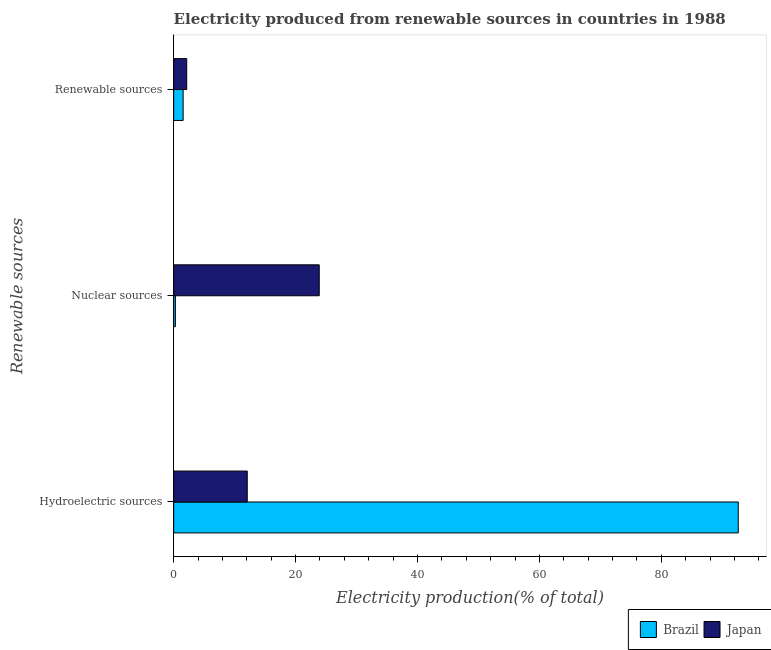How many different coloured bars are there?
Offer a terse response. 2. Are the number of bars per tick equal to the number of legend labels?
Offer a very short reply. Yes. How many bars are there on the 2nd tick from the bottom?
Offer a very short reply. 2. What is the label of the 3rd group of bars from the top?
Keep it short and to the point. Hydroelectric sources. What is the percentage of electricity produced by renewable sources in Brazil?
Make the answer very short. 1.55. Across all countries, what is the maximum percentage of electricity produced by renewable sources?
Give a very brief answer. 2.14. Across all countries, what is the minimum percentage of electricity produced by hydroelectric sources?
Your response must be concise. 12.07. What is the total percentage of electricity produced by nuclear sources in the graph?
Your answer should be compact. 24.16. What is the difference between the percentage of electricity produced by nuclear sources in Japan and that in Brazil?
Your answer should be compact. 23.6. What is the difference between the percentage of electricity produced by renewable sources in Brazil and the percentage of electricity produced by nuclear sources in Japan?
Your answer should be very brief. -22.33. What is the average percentage of electricity produced by nuclear sources per country?
Provide a succinct answer. 12.08. What is the difference between the percentage of electricity produced by nuclear sources and percentage of electricity produced by renewable sources in Japan?
Ensure brevity in your answer.  21.74. In how many countries, is the percentage of electricity produced by renewable sources greater than 4 %?
Offer a terse response. 0. What is the ratio of the percentage of electricity produced by nuclear sources in Japan to that in Brazil?
Your answer should be compact. 84.43. Is the percentage of electricity produced by nuclear sources in Brazil less than that in Japan?
Make the answer very short. Yes. Is the difference between the percentage of electricity produced by renewable sources in Japan and Brazil greater than the difference between the percentage of electricity produced by nuclear sources in Japan and Brazil?
Ensure brevity in your answer.  No. What is the difference between the highest and the second highest percentage of electricity produced by renewable sources?
Ensure brevity in your answer.  0.58. What is the difference between the highest and the lowest percentage of electricity produced by hydroelectric sources?
Offer a very short reply. 80.56. In how many countries, is the percentage of electricity produced by nuclear sources greater than the average percentage of electricity produced by nuclear sources taken over all countries?
Your answer should be very brief. 1. Is the sum of the percentage of electricity produced by hydroelectric sources in Brazil and Japan greater than the maximum percentage of electricity produced by nuclear sources across all countries?
Provide a succinct answer. Yes. What does the 2nd bar from the bottom in Hydroelectric sources represents?
Ensure brevity in your answer.  Japan. Is it the case that in every country, the sum of the percentage of electricity produced by hydroelectric sources and percentage of electricity produced by nuclear sources is greater than the percentage of electricity produced by renewable sources?
Offer a very short reply. Yes. Are all the bars in the graph horizontal?
Keep it short and to the point. Yes. What is the difference between two consecutive major ticks on the X-axis?
Keep it short and to the point. 20. Are the values on the major ticks of X-axis written in scientific E-notation?
Make the answer very short. No. Does the graph contain grids?
Your response must be concise. No. Where does the legend appear in the graph?
Your answer should be very brief. Bottom right. How many legend labels are there?
Ensure brevity in your answer.  2. What is the title of the graph?
Your answer should be very brief. Electricity produced from renewable sources in countries in 1988. Does "Cuba" appear as one of the legend labels in the graph?
Offer a terse response. No. What is the label or title of the X-axis?
Make the answer very short. Electricity production(% of total). What is the label or title of the Y-axis?
Your response must be concise. Renewable sources. What is the Electricity production(% of total) in Brazil in Hydroelectric sources?
Keep it short and to the point. 92.62. What is the Electricity production(% of total) in Japan in Hydroelectric sources?
Offer a very short reply. 12.07. What is the Electricity production(% of total) in Brazil in Nuclear sources?
Keep it short and to the point. 0.28. What is the Electricity production(% of total) of Japan in Nuclear sources?
Make the answer very short. 23.88. What is the Electricity production(% of total) in Brazil in Renewable sources?
Make the answer very short. 1.55. What is the Electricity production(% of total) in Japan in Renewable sources?
Your answer should be compact. 2.14. Across all Renewable sources, what is the maximum Electricity production(% of total) of Brazil?
Ensure brevity in your answer.  92.62. Across all Renewable sources, what is the maximum Electricity production(% of total) in Japan?
Give a very brief answer. 23.88. Across all Renewable sources, what is the minimum Electricity production(% of total) of Brazil?
Make the answer very short. 0.28. Across all Renewable sources, what is the minimum Electricity production(% of total) of Japan?
Your response must be concise. 2.14. What is the total Electricity production(% of total) in Brazil in the graph?
Provide a succinct answer. 94.46. What is the total Electricity production(% of total) in Japan in the graph?
Give a very brief answer. 38.09. What is the difference between the Electricity production(% of total) of Brazil in Hydroelectric sources and that in Nuclear sources?
Ensure brevity in your answer.  92.34. What is the difference between the Electricity production(% of total) in Japan in Hydroelectric sources and that in Nuclear sources?
Give a very brief answer. -11.81. What is the difference between the Electricity production(% of total) in Brazil in Hydroelectric sources and that in Renewable sources?
Your answer should be compact. 91.07. What is the difference between the Electricity production(% of total) in Japan in Hydroelectric sources and that in Renewable sources?
Give a very brief answer. 9.93. What is the difference between the Electricity production(% of total) of Brazil in Nuclear sources and that in Renewable sources?
Give a very brief answer. -1.27. What is the difference between the Electricity production(% of total) of Japan in Nuclear sources and that in Renewable sources?
Your answer should be compact. 21.74. What is the difference between the Electricity production(% of total) in Brazil in Hydroelectric sources and the Electricity production(% of total) in Japan in Nuclear sources?
Offer a terse response. 68.74. What is the difference between the Electricity production(% of total) in Brazil in Hydroelectric sources and the Electricity production(% of total) in Japan in Renewable sources?
Make the answer very short. 90.49. What is the difference between the Electricity production(% of total) in Brazil in Nuclear sources and the Electricity production(% of total) in Japan in Renewable sources?
Your answer should be very brief. -1.85. What is the average Electricity production(% of total) in Brazil per Renewable sources?
Give a very brief answer. 31.49. What is the average Electricity production(% of total) in Japan per Renewable sources?
Keep it short and to the point. 12.7. What is the difference between the Electricity production(% of total) in Brazil and Electricity production(% of total) in Japan in Hydroelectric sources?
Provide a short and direct response. 80.56. What is the difference between the Electricity production(% of total) of Brazil and Electricity production(% of total) of Japan in Nuclear sources?
Provide a succinct answer. -23.6. What is the difference between the Electricity production(% of total) in Brazil and Electricity production(% of total) in Japan in Renewable sources?
Your answer should be compact. -0.58. What is the ratio of the Electricity production(% of total) of Brazil in Hydroelectric sources to that in Nuclear sources?
Provide a short and direct response. 327.46. What is the ratio of the Electricity production(% of total) of Japan in Hydroelectric sources to that in Nuclear sources?
Ensure brevity in your answer.  0.51. What is the ratio of the Electricity production(% of total) in Brazil in Hydroelectric sources to that in Renewable sources?
Keep it short and to the point. 59.63. What is the ratio of the Electricity production(% of total) in Japan in Hydroelectric sources to that in Renewable sources?
Offer a terse response. 5.65. What is the ratio of the Electricity production(% of total) in Brazil in Nuclear sources to that in Renewable sources?
Your answer should be very brief. 0.18. What is the ratio of the Electricity production(% of total) of Japan in Nuclear sources to that in Renewable sources?
Offer a terse response. 11.18. What is the difference between the highest and the second highest Electricity production(% of total) in Brazil?
Give a very brief answer. 91.07. What is the difference between the highest and the second highest Electricity production(% of total) of Japan?
Your answer should be very brief. 11.81. What is the difference between the highest and the lowest Electricity production(% of total) in Brazil?
Provide a short and direct response. 92.34. What is the difference between the highest and the lowest Electricity production(% of total) of Japan?
Offer a very short reply. 21.74. 